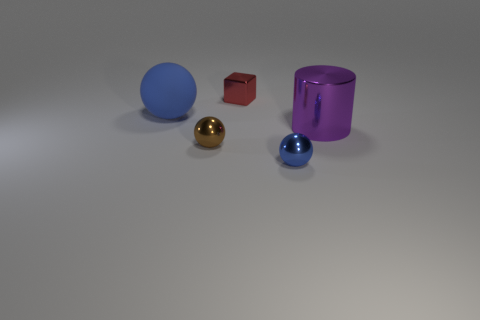How would you describe the lighting and shadows in the scene? The lighting in the image is soft and diffused, coming from above and creating gentle shadows that suggest it's an indoor setting with either natural light filtering in or artificial lighting that mimics daylight. The shadows are subtlety cast towards the right, indicating the light source is to the left of the objects. 